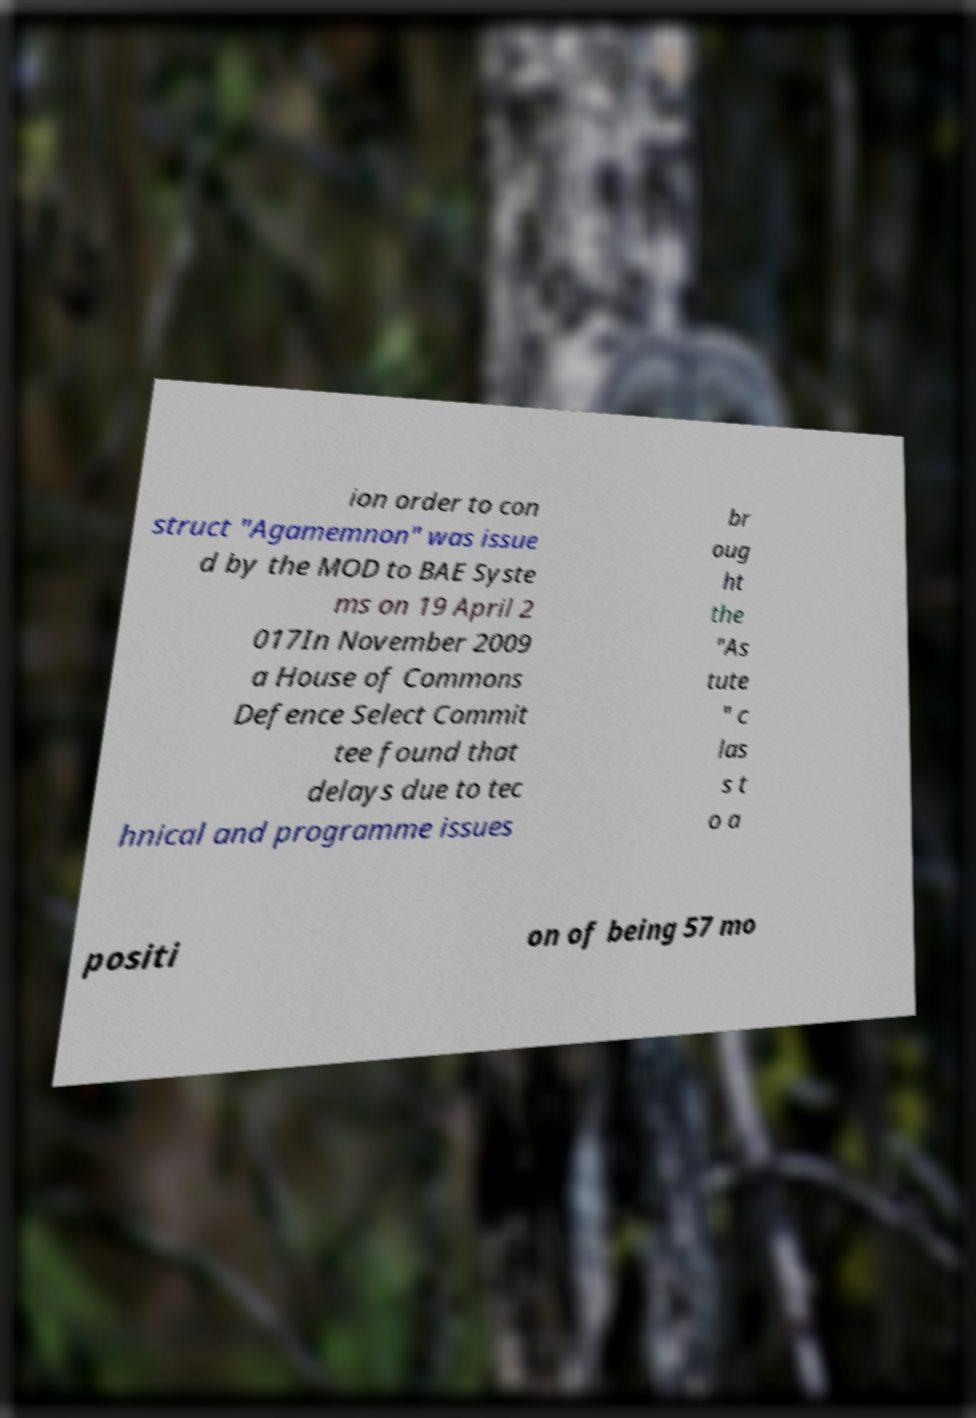Could you assist in decoding the text presented in this image and type it out clearly? ion order to con struct "Agamemnon" was issue d by the MOD to BAE Syste ms on 19 April 2 017In November 2009 a House of Commons Defence Select Commit tee found that delays due to tec hnical and programme issues br oug ht the "As tute " c las s t o a positi on of being 57 mo 